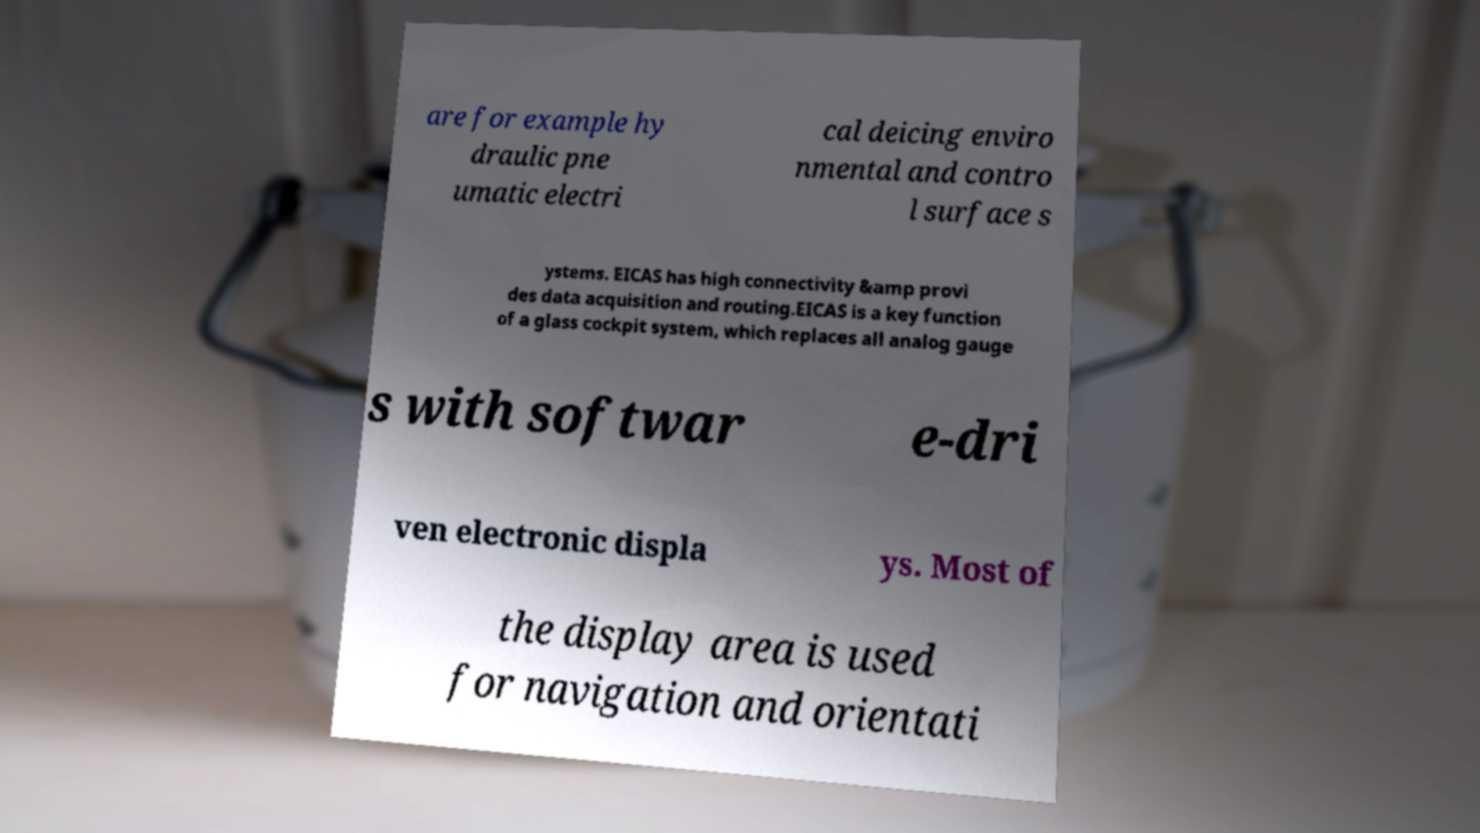For documentation purposes, I need the text within this image transcribed. Could you provide that? are for example hy draulic pne umatic electri cal deicing enviro nmental and contro l surface s ystems. EICAS has high connectivity &amp provi des data acquisition and routing.EICAS is a key function of a glass cockpit system, which replaces all analog gauge s with softwar e-dri ven electronic displa ys. Most of the display area is used for navigation and orientati 